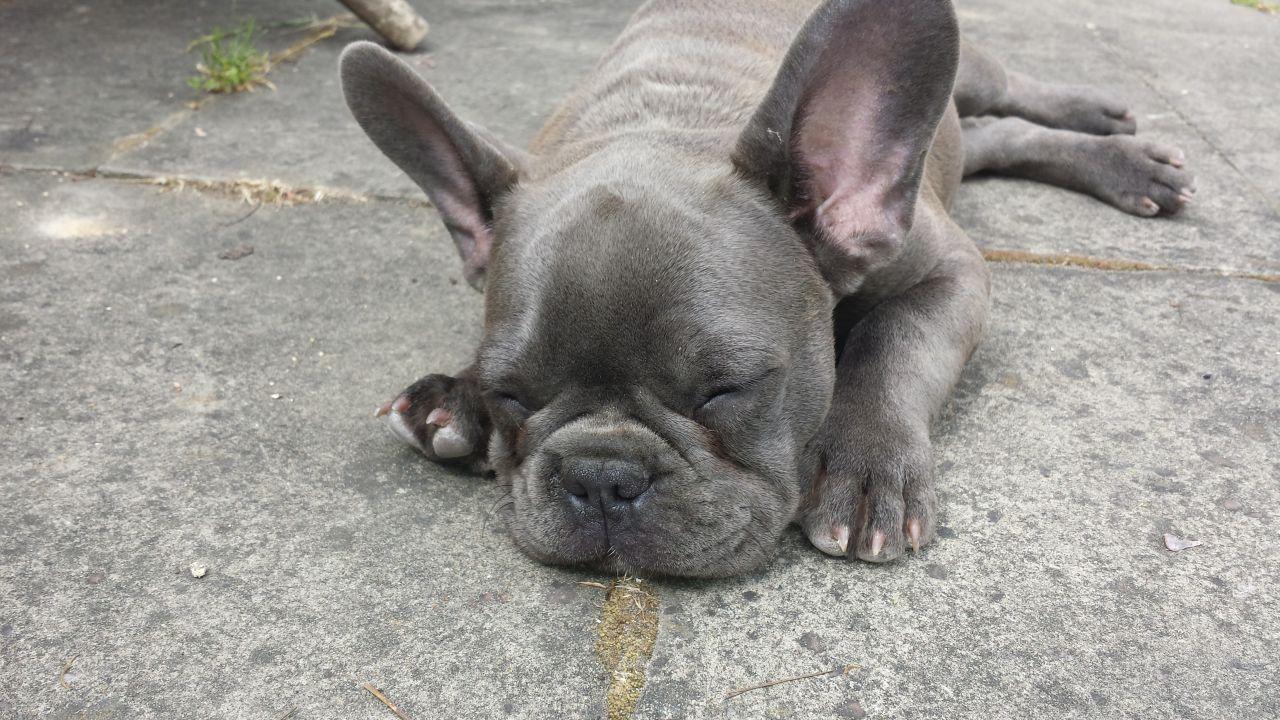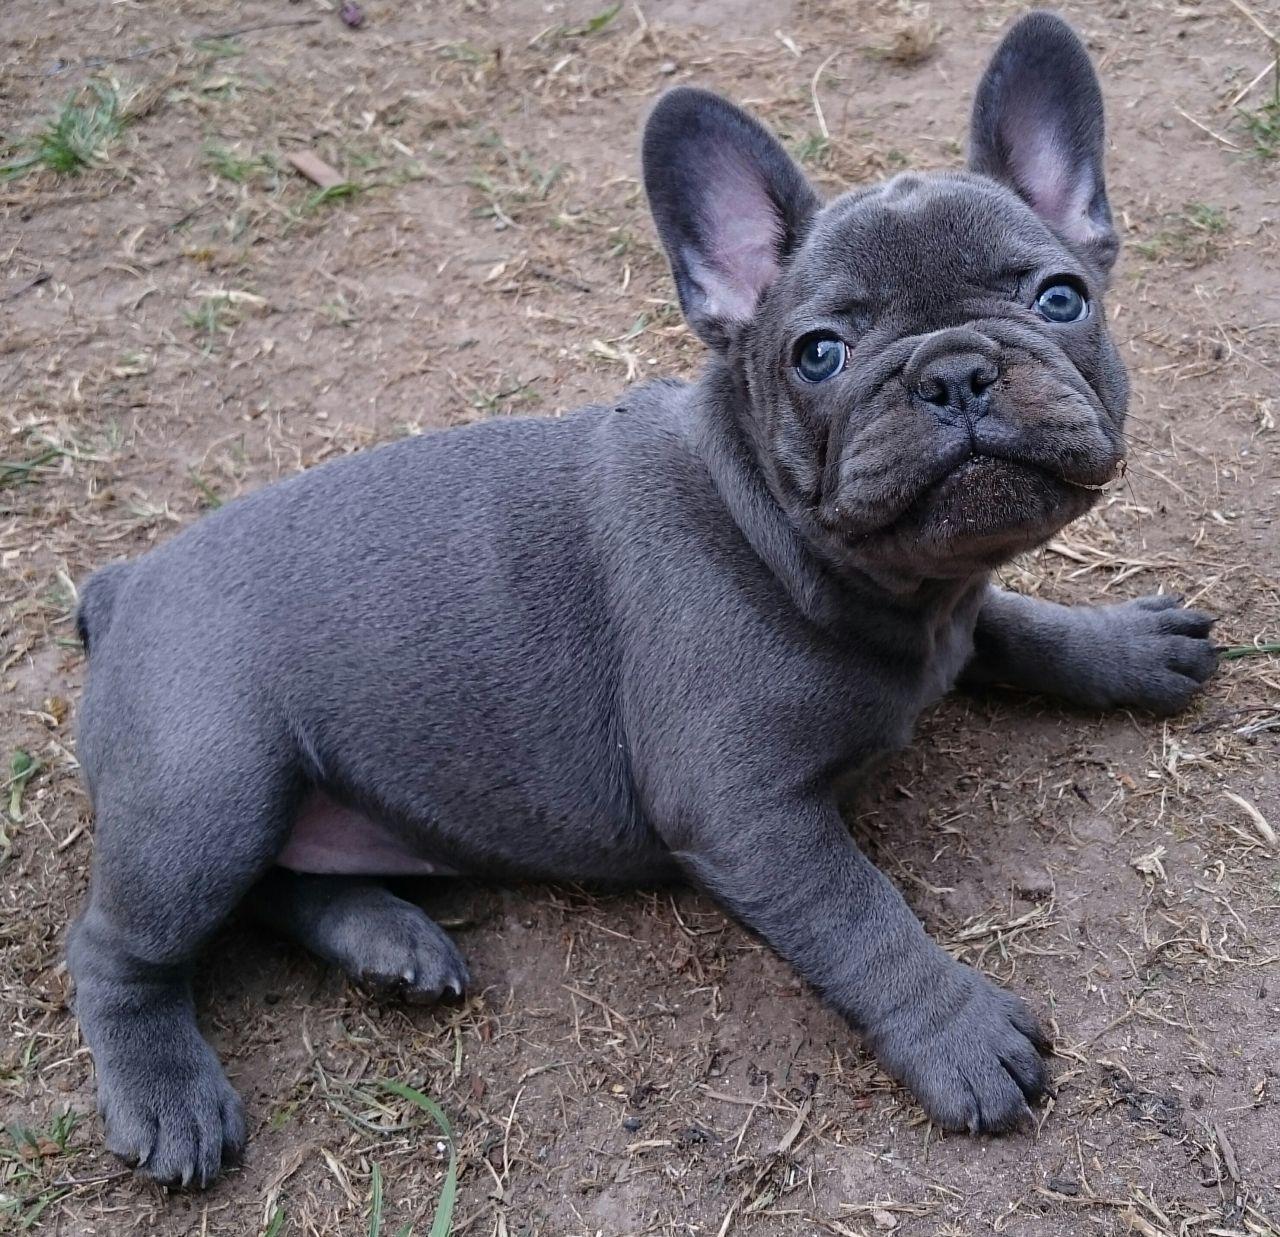The first image is the image on the left, the second image is the image on the right. Examine the images to the left and right. Is the description "Two dogs are relaxing on the ground." accurate? Answer yes or no. Yes. The first image is the image on the left, the second image is the image on the right. For the images displayed, is the sentence "An image shows exactly one gray big-eared dog, and it is wearing something." factually correct? Answer yes or no. No. 